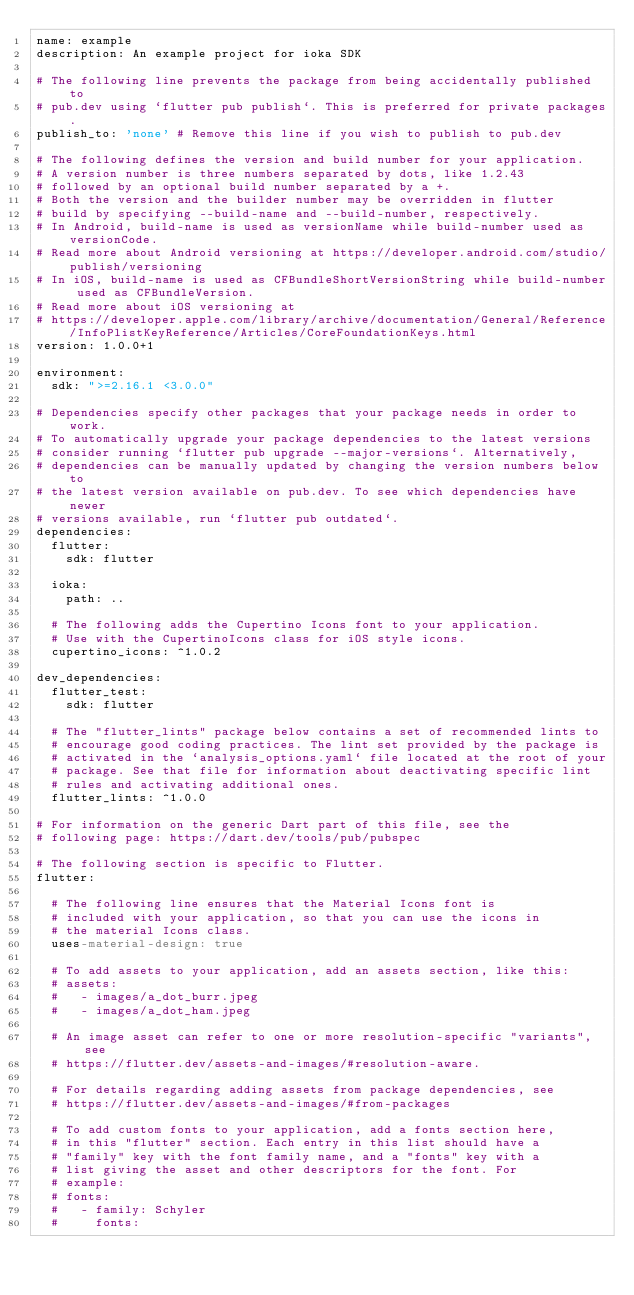Convert code to text. <code><loc_0><loc_0><loc_500><loc_500><_YAML_>name: example
description: An example project for ioka SDK

# The following line prevents the package from being accidentally published to
# pub.dev using `flutter pub publish`. This is preferred for private packages.
publish_to: 'none' # Remove this line if you wish to publish to pub.dev

# The following defines the version and build number for your application.
# A version number is three numbers separated by dots, like 1.2.43
# followed by an optional build number separated by a +.
# Both the version and the builder number may be overridden in flutter
# build by specifying --build-name and --build-number, respectively.
# In Android, build-name is used as versionName while build-number used as versionCode.
# Read more about Android versioning at https://developer.android.com/studio/publish/versioning
# In iOS, build-name is used as CFBundleShortVersionString while build-number used as CFBundleVersion.
# Read more about iOS versioning at
# https://developer.apple.com/library/archive/documentation/General/Reference/InfoPlistKeyReference/Articles/CoreFoundationKeys.html
version: 1.0.0+1

environment:
  sdk: ">=2.16.1 <3.0.0"

# Dependencies specify other packages that your package needs in order to work.
# To automatically upgrade your package dependencies to the latest versions
# consider running `flutter pub upgrade --major-versions`. Alternatively,
# dependencies can be manually updated by changing the version numbers below to
# the latest version available on pub.dev. To see which dependencies have newer
# versions available, run `flutter pub outdated`.
dependencies:
  flutter:
    sdk: flutter

  ioka: 
    path: ..

  # The following adds the Cupertino Icons font to your application.
  # Use with the CupertinoIcons class for iOS style icons.
  cupertino_icons: ^1.0.2

dev_dependencies:
  flutter_test:
    sdk: flutter

  # The "flutter_lints" package below contains a set of recommended lints to
  # encourage good coding practices. The lint set provided by the package is
  # activated in the `analysis_options.yaml` file located at the root of your
  # package. See that file for information about deactivating specific lint
  # rules and activating additional ones.
  flutter_lints: ^1.0.0

# For information on the generic Dart part of this file, see the
# following page: https://dart.dev/tools/pub/pubspec

# The following section is specific to Flutter.
flutter:

  # The following line ensures that the Material Icons font is
  # included with your application, so that you can use the icons in
  # the material Icons class.
  uses-material-design: true

  # To add assets to your application, add an assets section, like this:
  # assets:
  #   - images/a_dot_burr.jpeg
  #   - images/a_dot_ham.jpeg

  # An image asset can refer to one or more resolution-specific "variants", see
  # https://flutter.dev/assets-and-images/#resolution-aware.

  # For details regarding adding assets from package dependencies, see
  # https://flutter.dev/assets-and-images/#from-packages

  # To add custom fonts to your application, add a fonts section here,
  # in this "flutter" section. Each entry in this list should have a
  # "family" key with the font family name, and a "fonts" key with a
  # list giving the asset and other descriptors for the font. For
  # example:
  # fonts:
  #   - family: Schyler
  #     fonts:</code> 